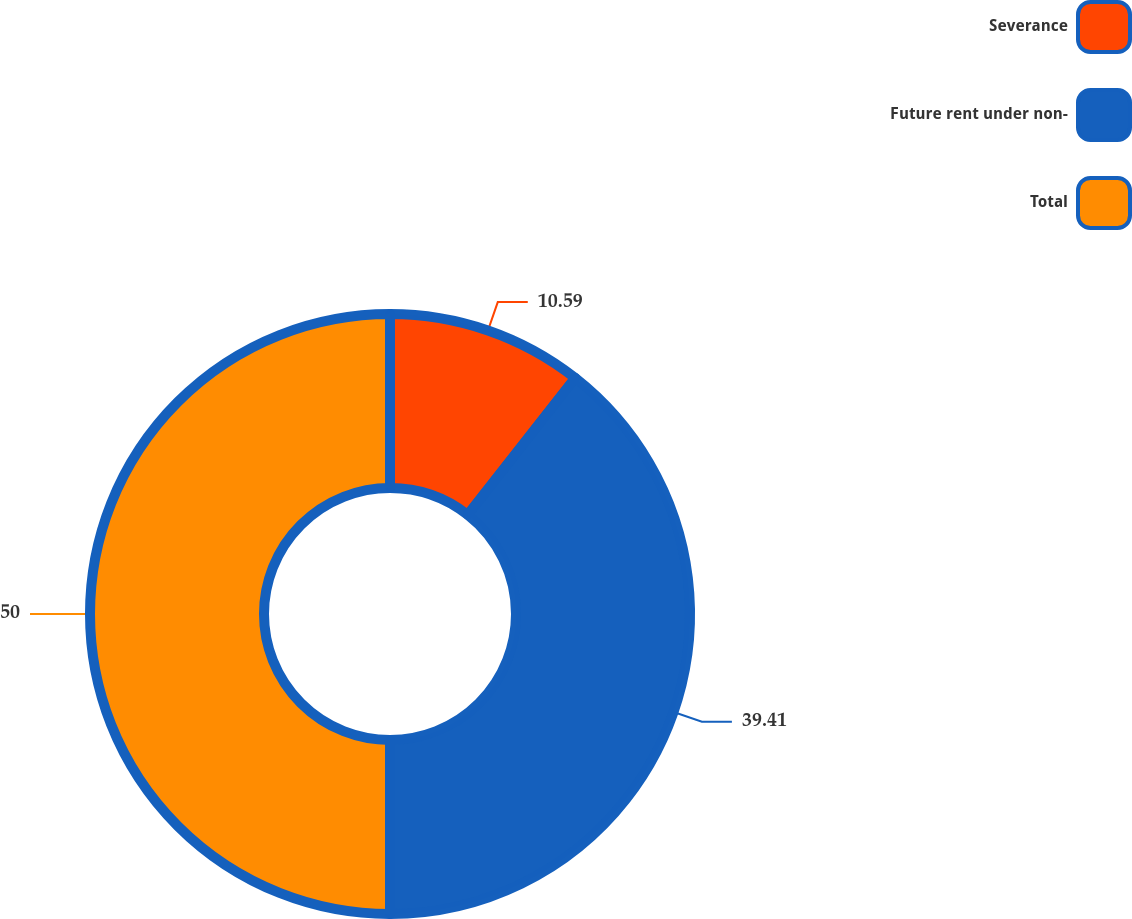<chart> <loc_0><loc_0><loc_500><loc_500><pie_chart><fcel>Severance<fcel>Future rent under non-<fcel>Total<nl><fcel>10.59%<fcel>39.41%<fcel>50.0%<nl></chart> 